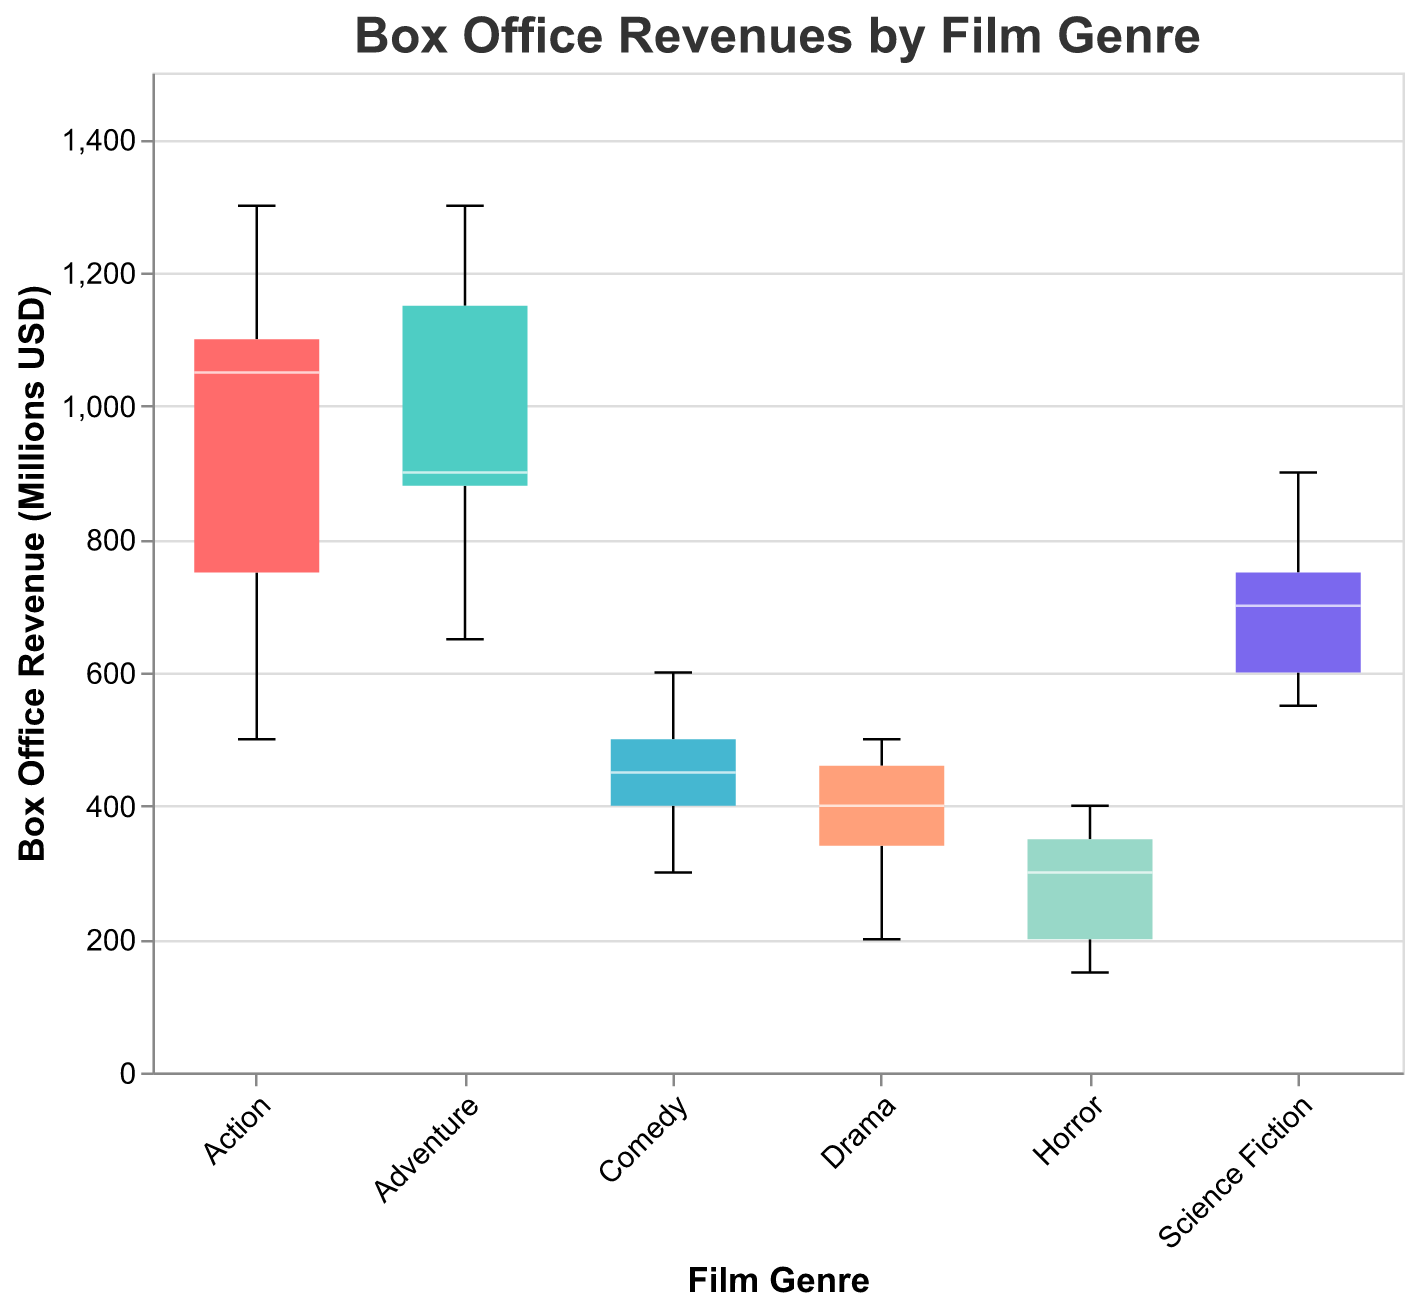What is the title of the figure? The title is located at the top of the figure and is generally the main heading that describes what is being shown.
Answer: Box Office Revenues by Film Genre What are the film genres included in the plot? The film genres are shown along the x-axis; they represent the different categories being analyzed.
Answer: Action, Adventure, Comedy, Drama, Horror, Science Fiction Which film genre has the highest median box office revenue? The median is indicated by the white line within each box. By comparing the positions of these lines across genres, the highest can be identified.
Answer: Action What is the range of box office revenues for the Horror genre? The range is determined by the distance between the minimum and maximum points or whiskers of the box plot for the Horror genre. The whiskers indicate the spread of the data.
Answer: 150 to 400 Which genre has the widest interquartile range (IQR) for box office revenue? The IQR is the distance between the first quartile (bottom of the box) and the third quartile (top of the box). The genre with the largest box represents the widest IQR.
Answer: Action How does the median box office revenue for Comedy compare to Drama? Compare the median lines (white lines) in the boxes for Comedy and Drama. The position of these lines relative to each other reveals the difference in medians.
Answer: Higher for Comedy What is the interquartile range (IQR) for the Action genre? Identify the positions of the first and third quartiles (bottom and top of the box, respectively) for Action, then subtract the first quartile value from the third quartile value.
Answer: 1050 - 750 = 300 Which genre shows the smallest variation in box office revenues? The smallest variation is indicated by the genre with the shortest distance between its minimum and maximum whiskers.
Answer: Drama Are there any outliers in the box office revenue data? If so, for which genres? Outliers are represented by points outside the whiskers of the box plots. Look for any red marks beyond the whiskers to find the outliers.
Answer: No outliers 